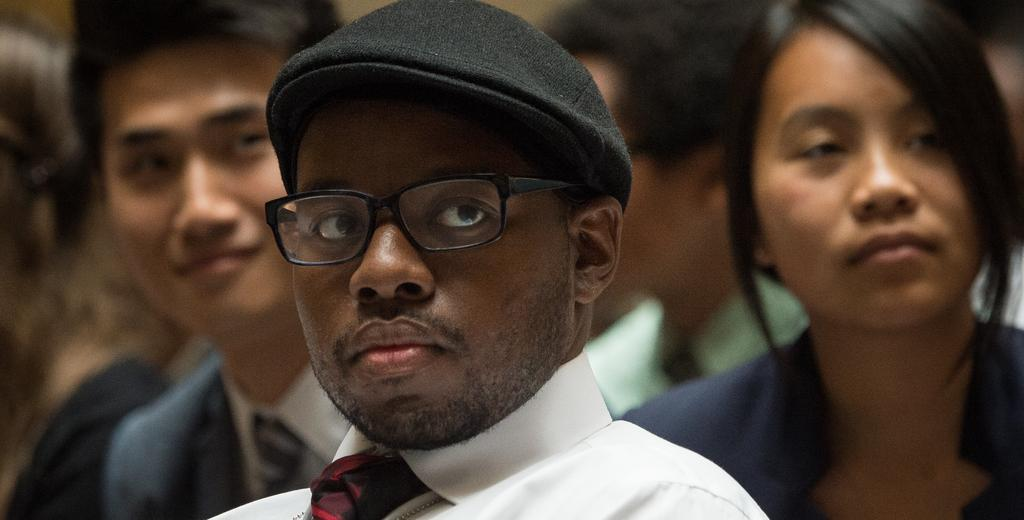How many people are in the image? There are people in the image. Can you describe the appearance of the man in the front of the image? The man in the front of the image is wearing a cap, spectacles, a white color shirt, and a tie. What is the background of the image like? The background of the image is blurred. How many geese are swimming in the image? There are no geese present in the image. What is the man in the front of the image wishing for in the image? There is no indication of the man's wishes in the image. 